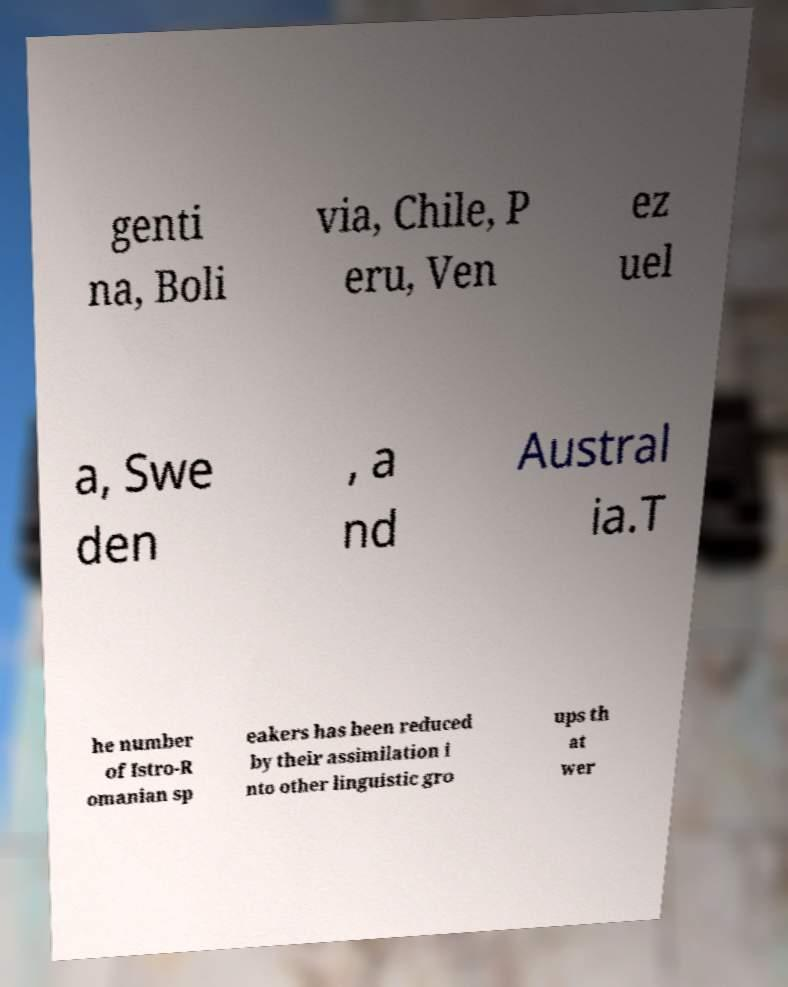What messages or text are displayed in this image? I need them in a readable, typed format. genti na, Boli via, Chile, P eru, Ven ez uel a, Swe den , a nd Austral ia.T he number of Istro-R omanian sp eakers has been reduced by their assimilation i nto other linguistic gro ups th at wer 